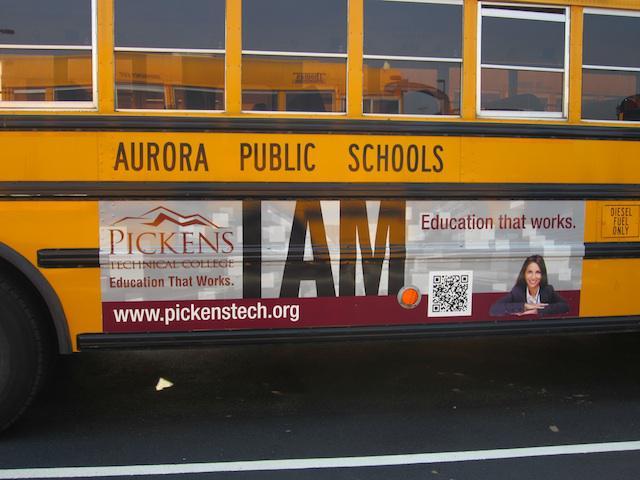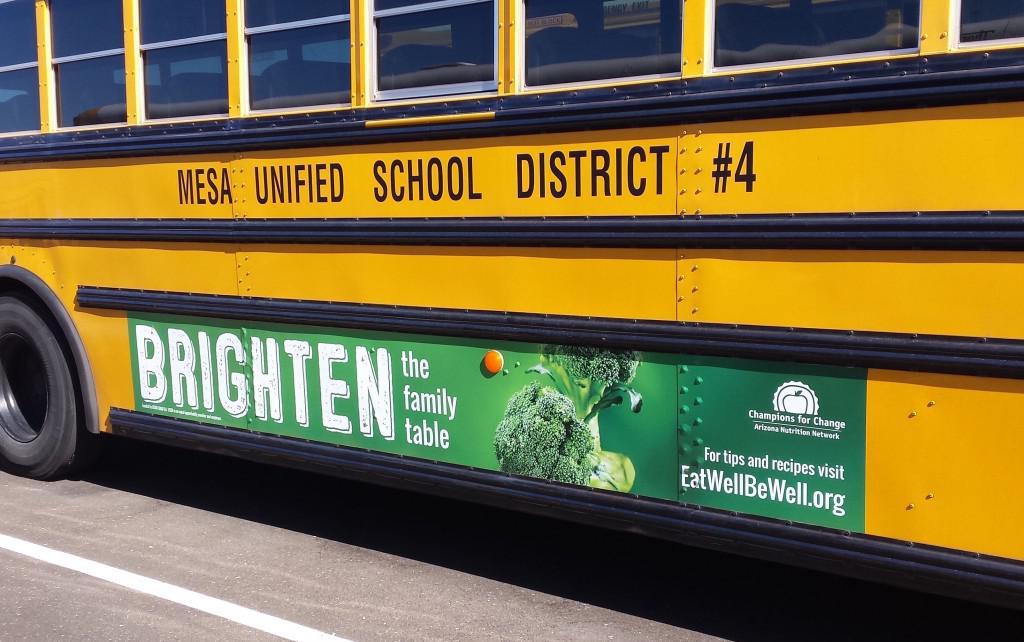The first image is the image on the left, the second image is the image on the right. For the images displayed, is the sentence "All images show a sign on the side of a school bus that contains at least one human face, and at least one image features a school bus sign with multiple kids faces on it." factually correct? Answer yes or no. No. The first image is the image on the left, the second image is the image on the right. Evaluate the accuracy of this statement regarding the images: "There is a bus with at least one shild in the advertizing on the side of the bus". Is it true? Answer yes or no. No. 